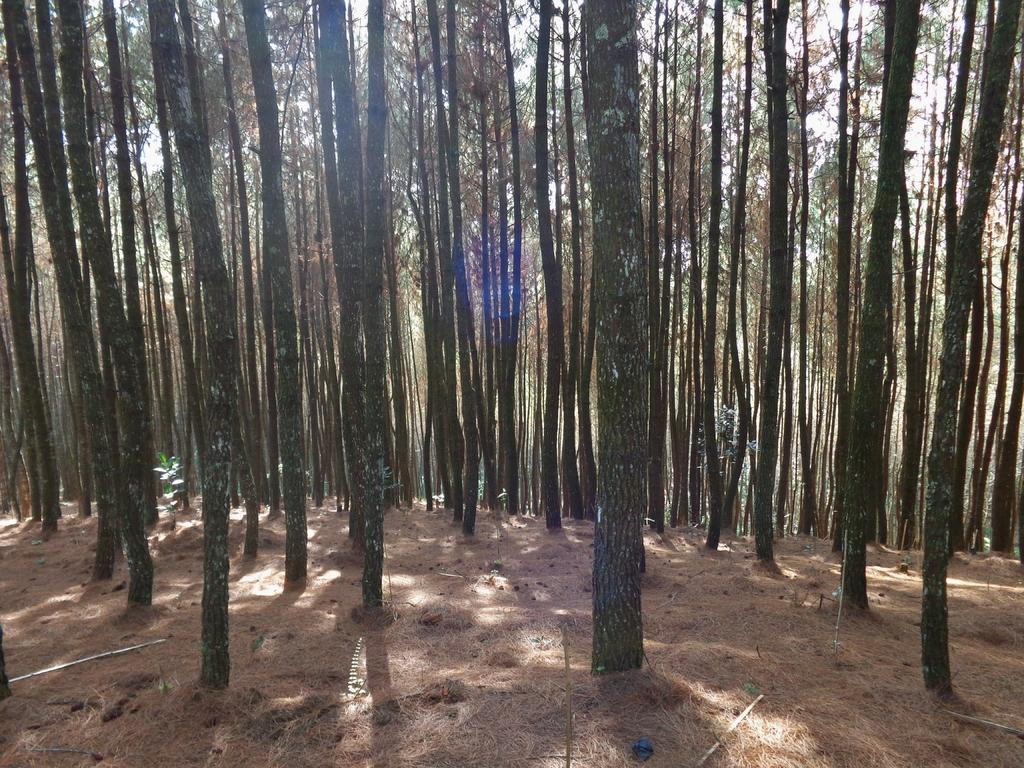What type of vegetation can be seen in the image? There are trees in the image. What can be found on the ground in the image? There are white objects on the ground in the image. How many babies are sitting on the wall in the image? There is no wall or babies present in the image. What type of fruit can be seen hanging from the trees in the image? There is no mention of fruit in the image, only trees and white objects on the ground. 